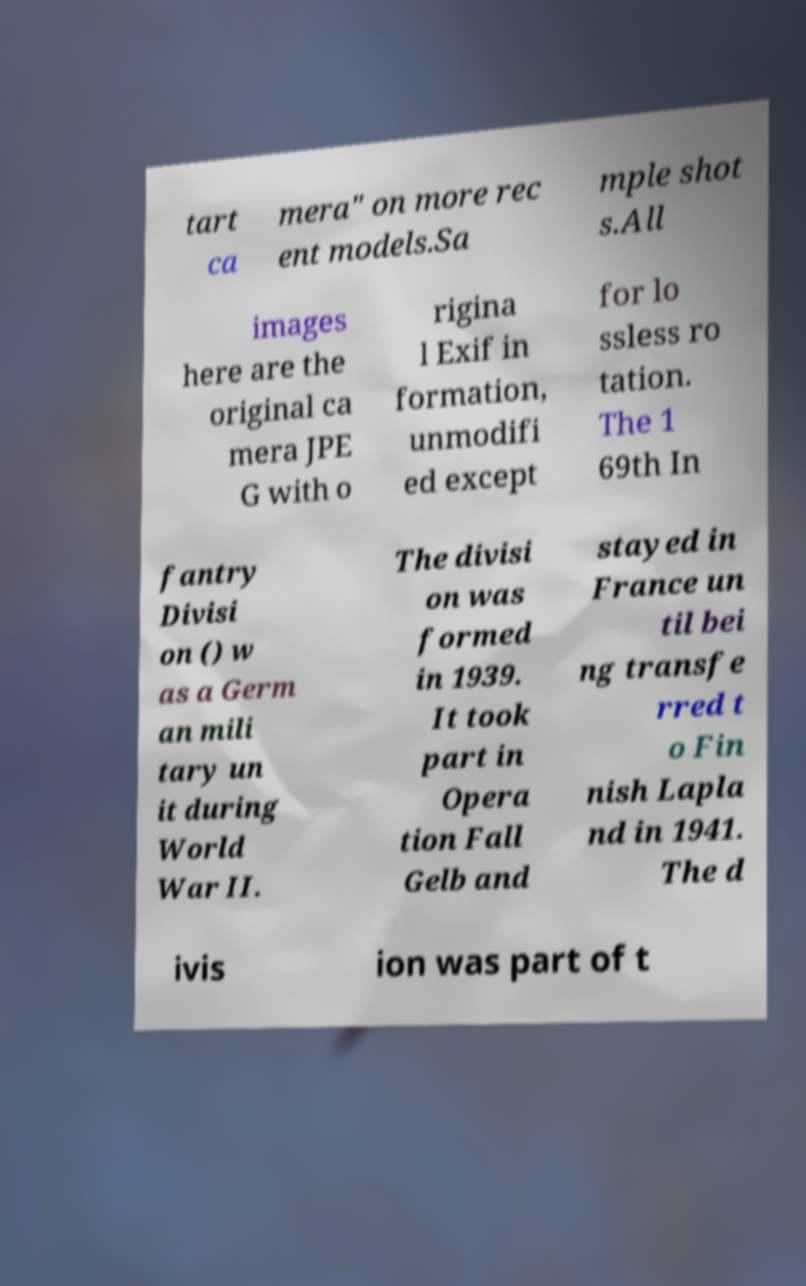Can you read and provide the text displayed in the image?This photo seems to have some interesting text. Can you extract and type it out for me? tart ca mera" on more rec ent models.Sa mple shot s.All images here are the original ca mera JPE G with o rigina l Exif in formation, unmodifi ed except for lo ssless ro tation. The 1 69th In fantry Divisi on () w as a Germ an mili tary un it during World War II. The divisi on was formed in 1939. It took part in Opera tion Fall Gelb and stayed in France un til bei ng transfe rred t o Fin nish Lapla nd in 1941. The d ivis ion was part of t 